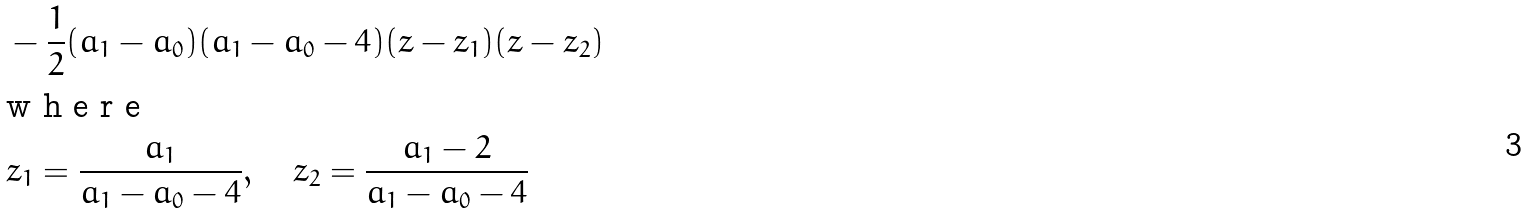Convert formula to latex. <formula><loc_0><loc_0><loc_500><loc_500>& - \frac { 1 } { 2 } ( a _ { 1 } - a _ { 0 } ) ( a _ { 1 } - a _ { 0 } - 4 ) ( z - z _ { 1 } ) ( z - z _ { 2 } ) \intertext { w h e r e } & z _ { 1 } = \frac { a _ { 1 } } { a _ { 1 } - a _ { 0 } - 4 } , \quad z _ { 2 } = \frac { a _ { 1 } - 2 } { a _ { 1 } - a _ { 0 } - 4 }</formula> 